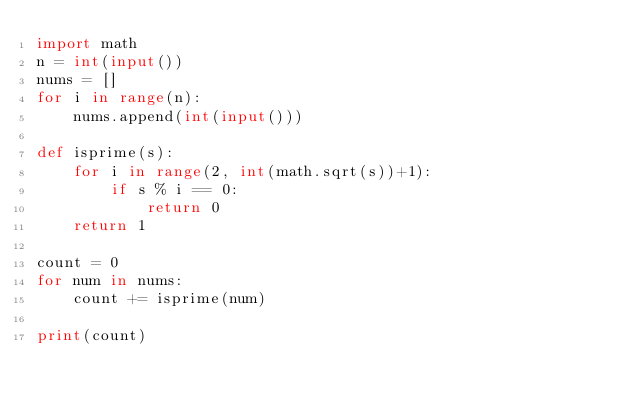<code> <loc_0><loc_0><loc_500><loc_500><_Python_>import math
n = int(input())
nums = []
for i in range(n):
    nums.append(int(input()))

def isprime(s):
    for i in range(2, int(math.sqrt(s))+1):
        if s % i == 0:
            return 0
    return 1

count = 0
for num in nums:
    count += isprime(num)
    
print(count)
</code> 